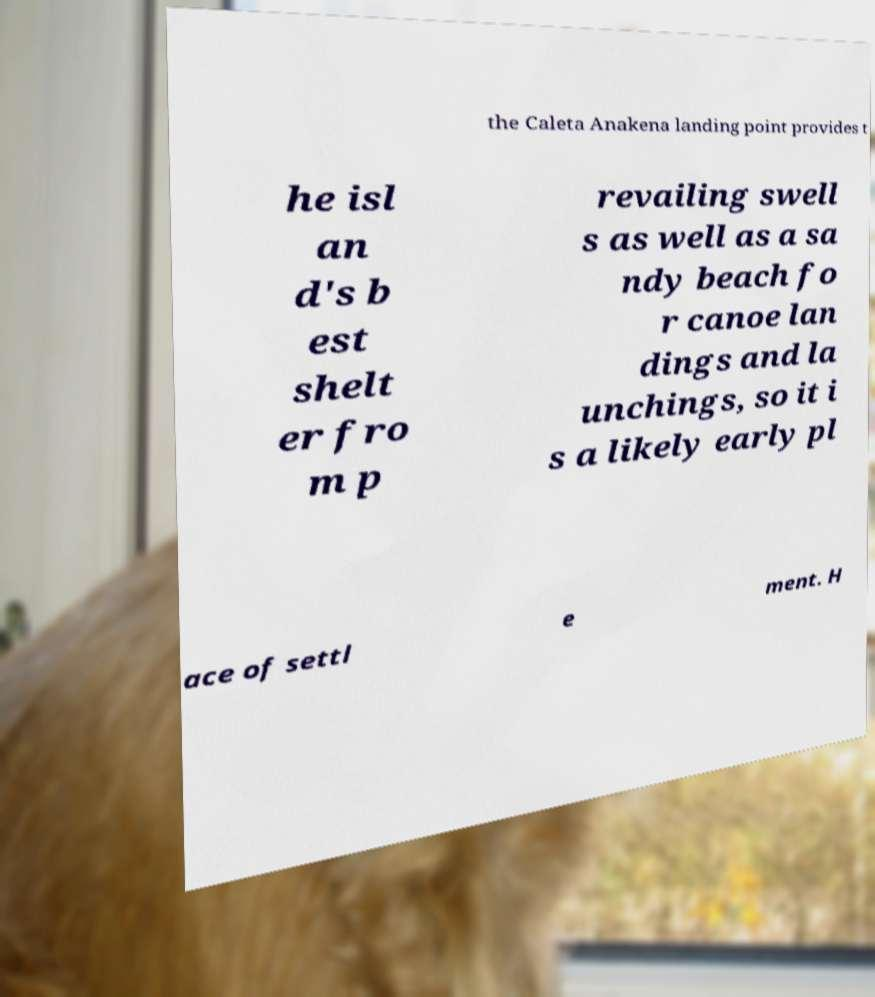There's text embedded in this image that I need extracted. Can you transcribe it verbatim? the Caleta Anakena landing point provides t he isl an d's b est shelt er fro m p revailing swell s as well as a sa ndy beach fo r canoe lan dings and la unchings, so it i s a likely early pl ace of settl e ment. H 